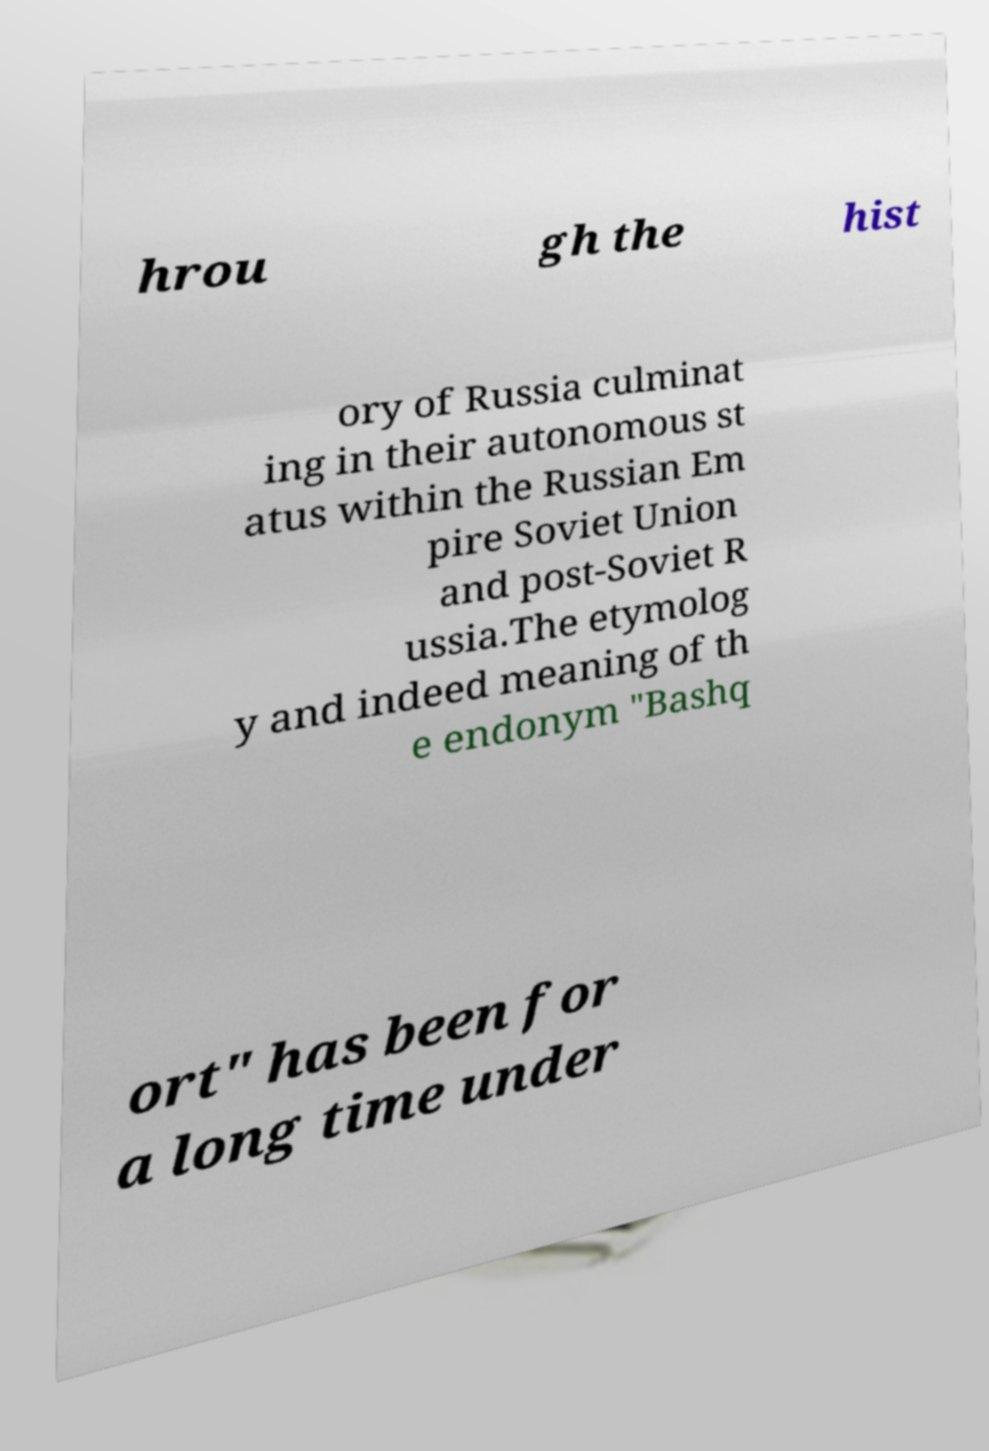Could you assist in decoding the text presented in this image and type it out clearly? hrou gh the hist ory of Russia culminat ing in their autonomous st atus within the Russian Em pire Soviet Union and post-Soviet R ussia.The etymolog y and indeed meaning of th e endonym "Bashq ort" has been for a long time under 